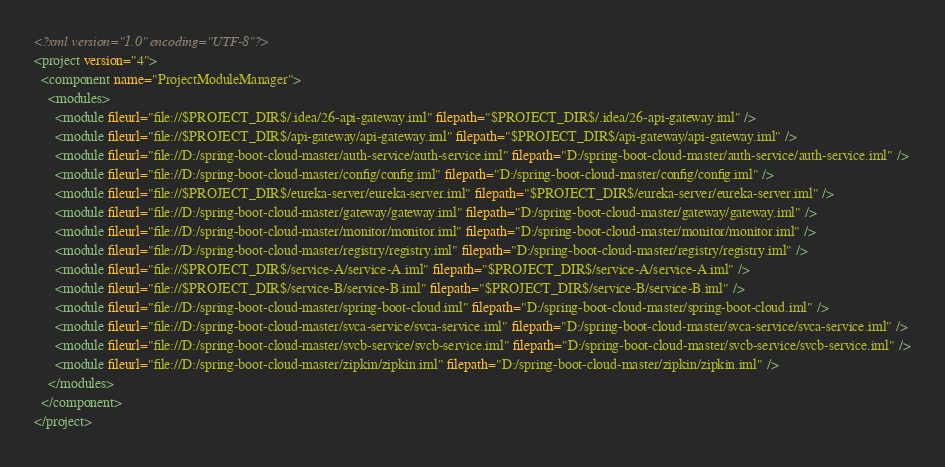<code> <loc_0><loc_0><loc_500><loc_500><_XML_><?xml version="1.0" encoding="UTF-8"?>
<project version="4">
  <component name="ProjectModuleManager">
    <modules>
      <module fileurl="file://$PROJECT_DIR$/.idea/26-api-gateway.iml" filepath="$PROJECT_DIR$/.idea/26-api-gateway.iml" />
      <module fileurl="file://$PROJECT_DIR$/api-gateway/api-gateway.iml" filepath="$PROJECT_DIR$/api-gateway/api-gateway.iml" />
      <module fileurl="file://D:/spring-boot-cloud-master/auth-service/auth-service.iml" filepath="D:/spring-boot-cloud-master/auth-service/auth-service.iml" />
      <module fileurl="file://D:/spring-boot-cloud-master/config/config.iml" filepath="D:/spring-boot-cloud-master/config/config.iml" />
      <module fileurl="file://$PROJECT_DIR$/eureka-server/eureka-server.iml" filepath="$PROJECT_DIR$/eureka-server/eureka-server.iml" />
      <module fileurl="file://D:/spring-boot-cloud-master/gateway/gateway.iml" filepath="D:/spring-boot-cloud-master/gateway/gateway.iml" />
      <module fileurl="file://D:/spring-boot-cloud-master/monitor/monitor.iml" filepath="D:/spring-boot-cloud-master/monitor/monitor.iml" />
      <module fileurl="file://D:/spring-boot-cloud-master/registry/registry.iml" filepath="D:/spring-boot-cloud-master/registry/registry.iml" />
      <module fileurl="file://$PROJECT_DIR$/service-A/service-A.iml" filepath="$PROJECT_DIR$/service-A/service-A.iml" />
      <module fileurl="file://$PROJECT_DIR$/service-B/service-B.iml" filepath="$PROJECT_DIR$/service-B/service-B.iml" />
      <module fileurl="file://D:/spring-boot-cloud-master/spring-boot-cloud.iml" filepath="D:/spring-boot-cloud-master/spring-boot-cloud.iml" />
      <module fileurl="file://D:/spring-boot-cloud-master/svca-service/svca-service.iml" filepath="D:/spring-boot-cloud-master/svca-service/svca-service.iml" />
      <module fileurl="file://D:/spring-boot-cloud-master/svcb-service/svcb-service.iml" filepath="D:/spring-boot-cloud-master/svcb-service/svcb-service.iml" />
      <module fileurl="file://D:/spring-boot-cloud-master/zipkin/zipkin.iml" filepath="D:/spring-boot-cloud-master/zipkin/zipkin.iml" />
    </modules>
  </component>
</project></code> 